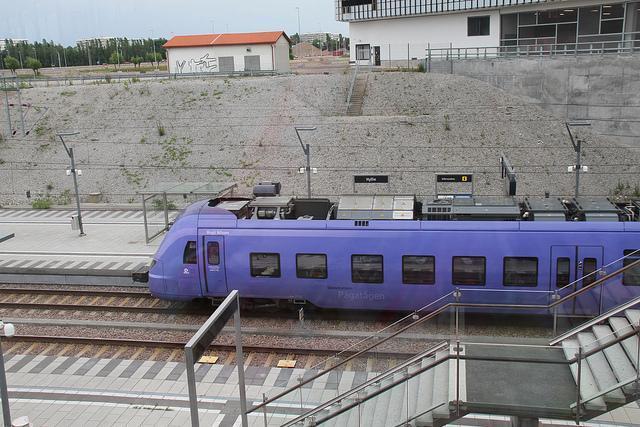How many people are wearing glasses?
Give a very brief answer. 0. 